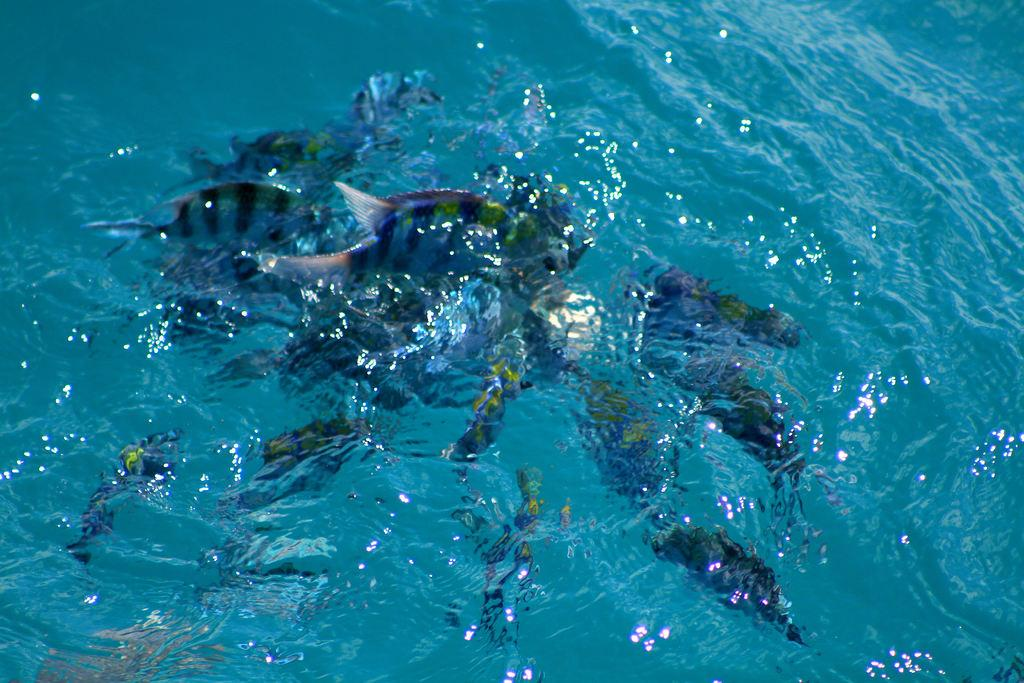What is the primary element visible in the image? There is water in the image. Can you describe any objects or features within the water? There is an unspecified object present in the water. Are there any jellyfish attacking the object in the water? There is no mention of jellyfish or any attack in the image. The image only shows water with an unspecified object present. 